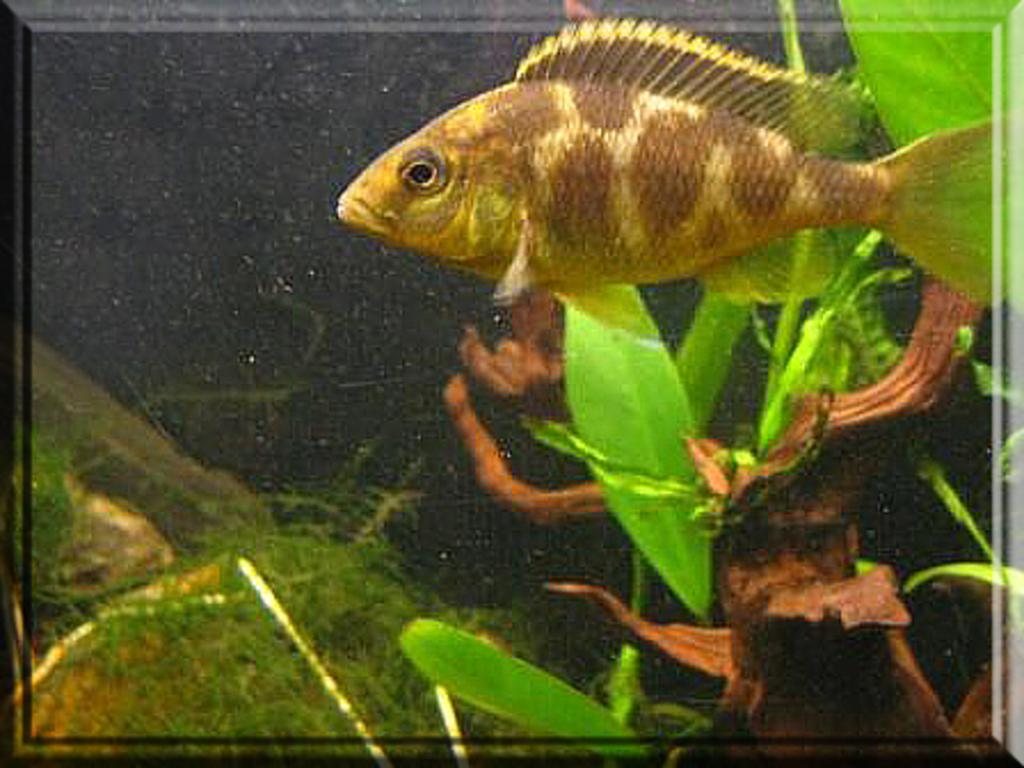What type of animal is in the image? There is a fish in the image. What color is the fish? The fish is brown in color. Where is the fish located in the image? The fish is at the top of the image. What else can be seen in the water in the image? There are plants in the water at the bottom of the image. What type of furniture is being offered in the image? There is no furniture present in the image; it features a brown fish at the top of the water with plants at the bottom. 